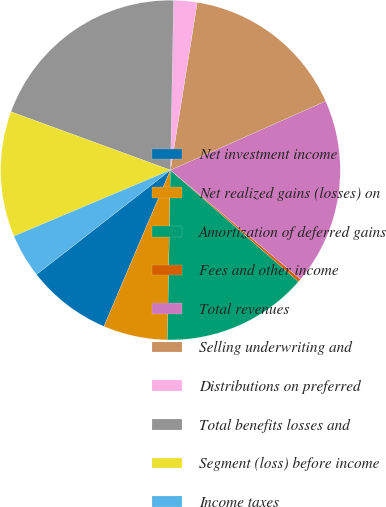Convert chart to OTSL. <chart><loc_0><loc_0><loc_500><loc_500><pie_chart><fcel>Net investment income<fcel>Net realized gains (losses) on<fcel>Amortization of deferred gains<fcel>Fees and other income<fcel>Total revenues<fcel>Selling underwriting and<fcel>Distributions on preferred<fcel>Total benefits losses and<fcel>Segment (loss) before income<fcel>Income taxes<nl><fcel>8.06%<fcel>6.12%<fcel>13.88%<fcel>0.29%<fcel>17.77%<fcel>15.82%<fcel>2.23%<fcel>19.71%<fcel>11.94%<fcel>4.18%<nl></chart> 